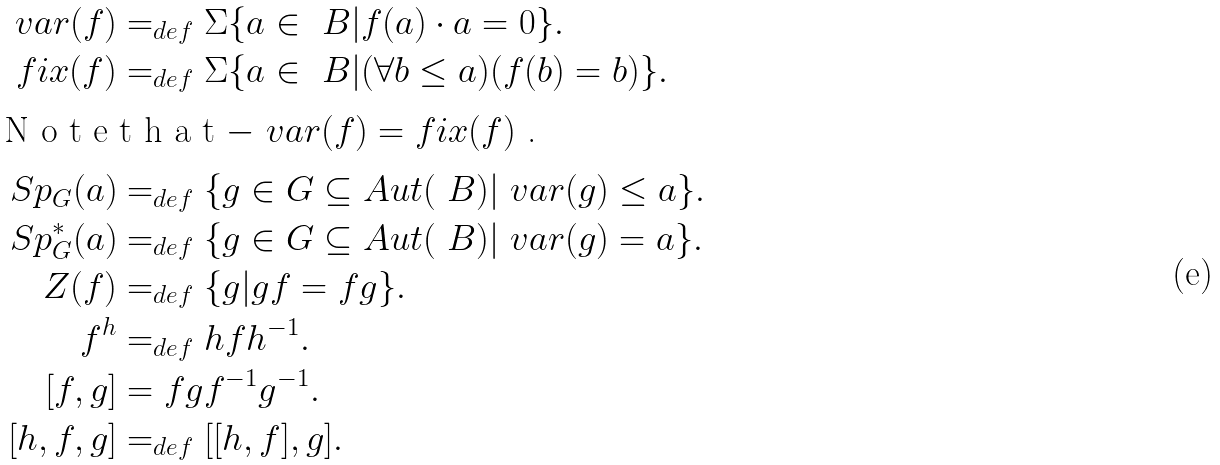Convert formula to latex. <formula><loc_0><loc_0><loc_500><loc_500>\ v a r ( f ) & = _ { d e f } \Sigma \{ a \in \ B | f ( a ) \cdot a = 0 \} . \\ f i x ( f ) & = _ { d e f } \Sigma \{ a \in \ B | ( \forall b \leq a ) ( f ( b ) = b ) \} . \\ \intertext { N o t e t h a t $ - \ v a r ( f ) = f i x ( f ) $ . } S p _ { G } ( a ) & = _ { d e f } \{ g \in G \subseteq A u t ( \ B ) | \ v a r ( g ) \leq a \} . \\ S p ^ { * } _ { G } ( a ) & = _ { d e f } \{ g \in G \subseteq A u t ( \ B ) | \ v a r ( g ) = a \} . \\ Z ( f ) & = _ { d e f } \{ g | g f = f g \} . \\ f ^ { h } & = _ { d e f } h f h ^ { - 1 } . \\ [ f , g ] & = f g f ^ { - 1 } g ^ { - 1 } . \\ [ h , f , g ] & = _ { d e f } [ [ h , f ] , g ] .</formula> 